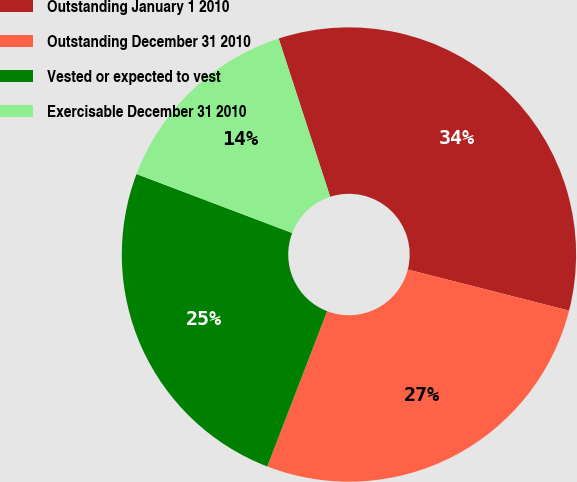Convert chart to OTSL. <chart><loc_0><loc_0><loc_500><loc_500><pie_chart><fcel>Outstanding January 1 2010<fcel>Outstanding December 31 2010<fcel>Vested or expected to vest<fcel>Exercisable December 31 2010<nl><fcel>33.98%<fcel>26.88%<fcel>24.91%<fcel>14.23%<nl></chart> 